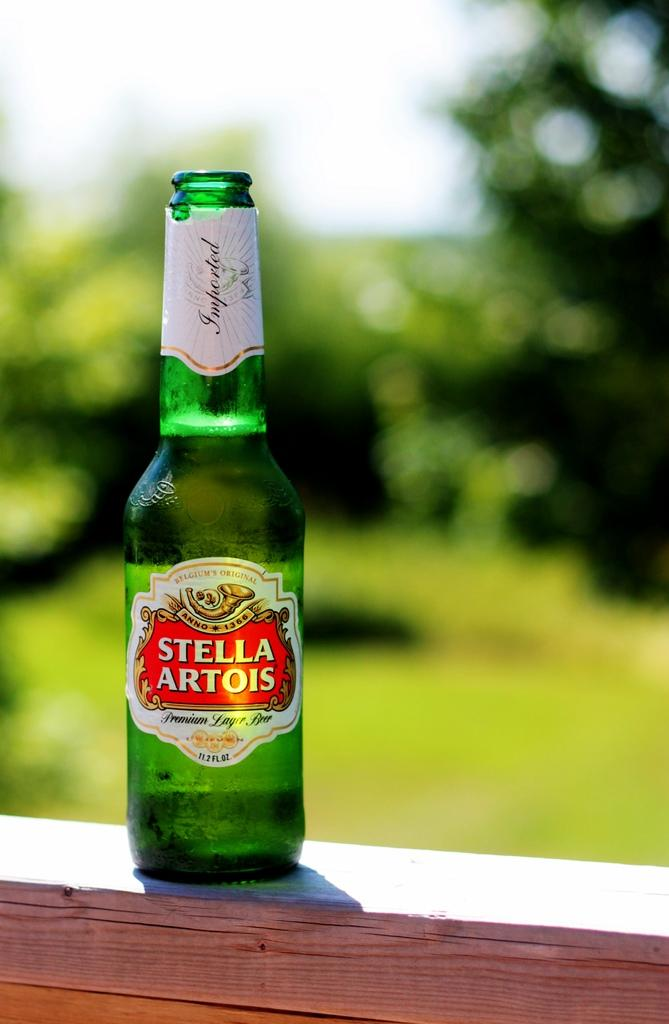<image>
Share a concise interpretation of the image provided. A bottle of Stella Artois sitting on top of a railing 